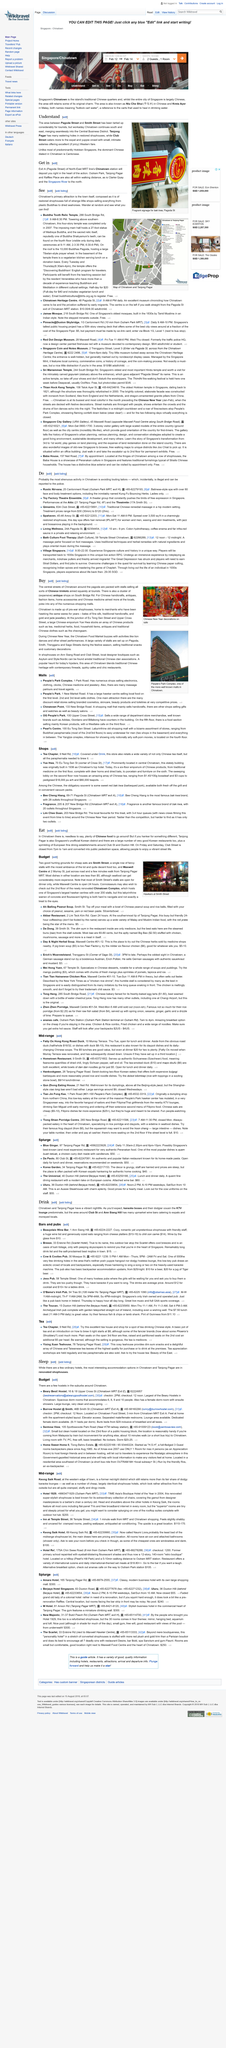Indicate a few pertinent items in this graphic. The title of the heading is "mid-range. The Chinatown MRT station has an Exit A, and this exit leads to Pagoda Street, where it intersects with Smith Street, and then onto Trengganu Street. Yue Hwa is a store that sells traditional Chinese clothing, and it is a great place to purchase such attire. The location of Tea Chapter is at 9 Neil Road. Yue Hwa is a shop located at 70 Eu Ton Sen Street that is based on 70 Eu Ton Sen Street. 